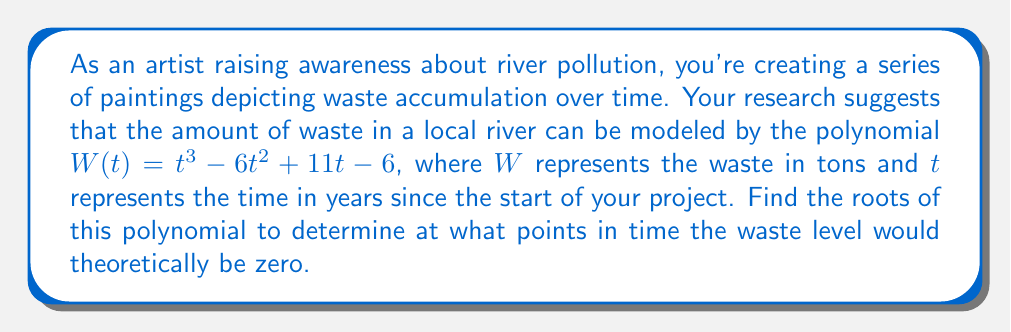Provide a solution to this math problem. To find the roots of the polynomial $W(t) = t^3 - 6t^2 + 11t - 6$, we need to factor it.

1) First, let's check if there are any rational roots using the rational root theorem. The possible rational roots are the factors of the constant term: $\pm 1, \pm 2, \pm 3, \pm 6$.

2) Testing these values, we find that $t = 1$ is a root:
   $W(1) = 1^3 - 6(1)^2 + 11(1) - 6 = 1 - 6 + 11 - 6 = 0$

3) We can factor out $(t - 1)$:
   $t^3 - 6t^2 + 11t - 6 = (t - 1)(t^2 - 5t + 6)$

4) The quadratic factor $t^2 - 5t + 6$ can be factored further:
   $t^2 - 5t + 6 = (t - 2)(t - 3)$

5) Therefore, the fully factored polynomial is:
   $W(t) = (t - 1)(t - 2)(t - 3)$

The roots of the polynomial are the values of $t$ that make each factor equal to zero. These are $t = 1$, $t = 2$, and $t = 3$.
Answer: The roots of the polynomial are 1, 2, and 3. 